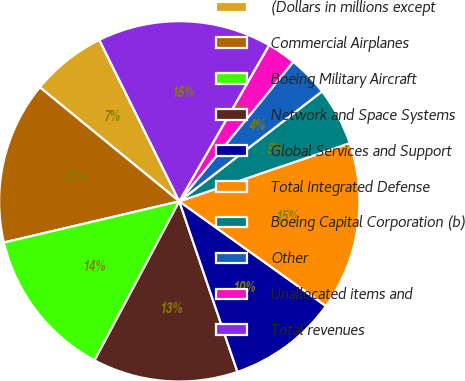Convert chart. <chart><loc_0><loc_0><loc_500><loc_500><pie_chart><fcel>(Dollars in millions except<fcel>Commercial Airplanes<fcel>Boeing Military Aircraft<fcel>Network and Space Systems<fcel>Global Services and Support<fcel>Total Integrated Defense<fcel>Boeing Capital Corporation (b)<fcel>Other<fcel>Unallocated items and<fcel>Total revenues<nl><fcel>6.77%<fcel>14.58%<fcel>13.54%<fcel>13.02%<fcel>9.9%<fcel>15.1%<fcel>5.21%<fcel>3.65%<fcel>2.6%<fcel>15.62%<nl></chart> 